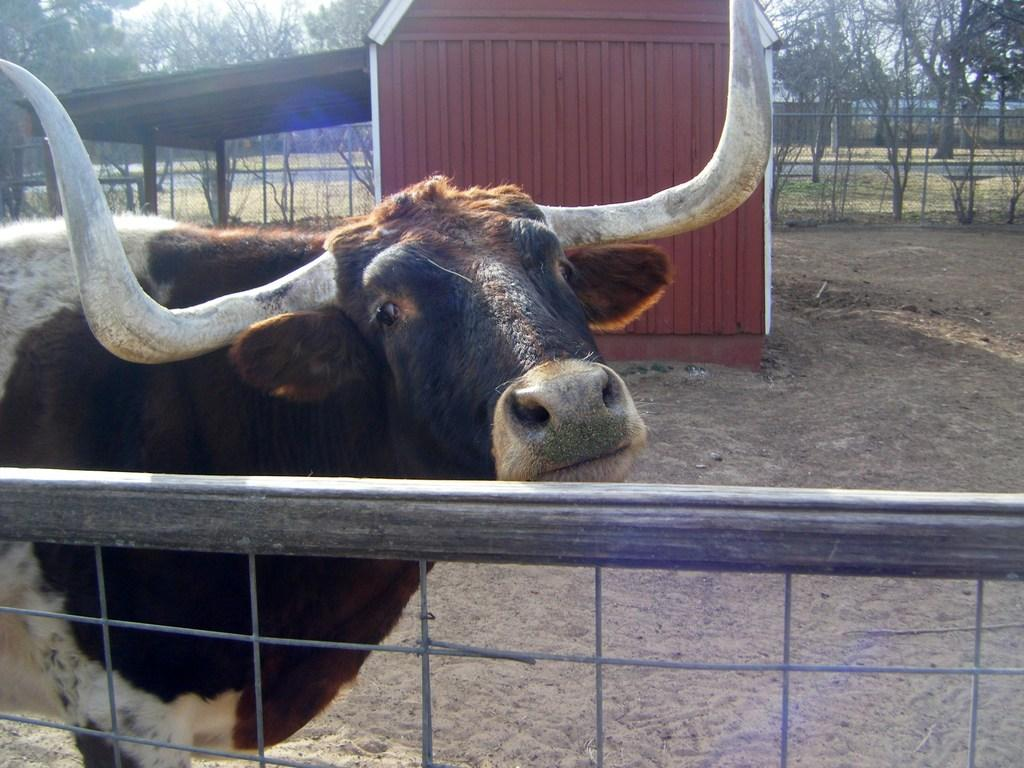What type of animal is in the picture? There is an animal in the picture, but the specific type cannot be determined from the provided facts. Can you describe the color of the animal? The animal is white and brown in color. What can be seen in the background of the image? There is a shed and trees in the background of the image. What type of veil is the secretary wearing in the image? There is no secretary or veil present in the image; it features an animal and background elements. 